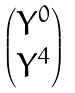Convert formula to latex. <formula><loc_0><loc_0><loc_500><loc_500>\begin{pmatrix} Y ^ { 0 } \\ Y ^ { 4 } \end{pmatrix}</formula> 